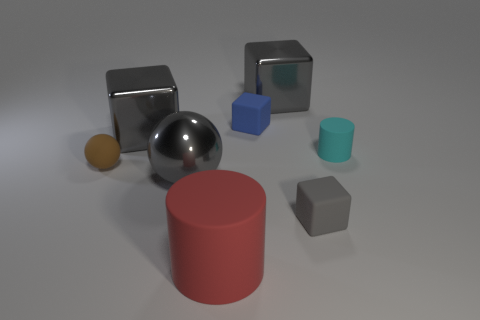What could be the possible uses for these objects in a real-world scenario? These objects, with their geometric shapes and varied materials, could serve several educational or design purposes. The metal-look objects might be used in a physics demonstration to explore light and reflection or as weights in a balance experiment. The colored cubes and cylinders could be part of a children's learning kit for understanding shapes, volume, and material textures, or even as stylish, minimalist office decor. The various textures and colors may also be beneficial for sensory development activities in early education settings. 